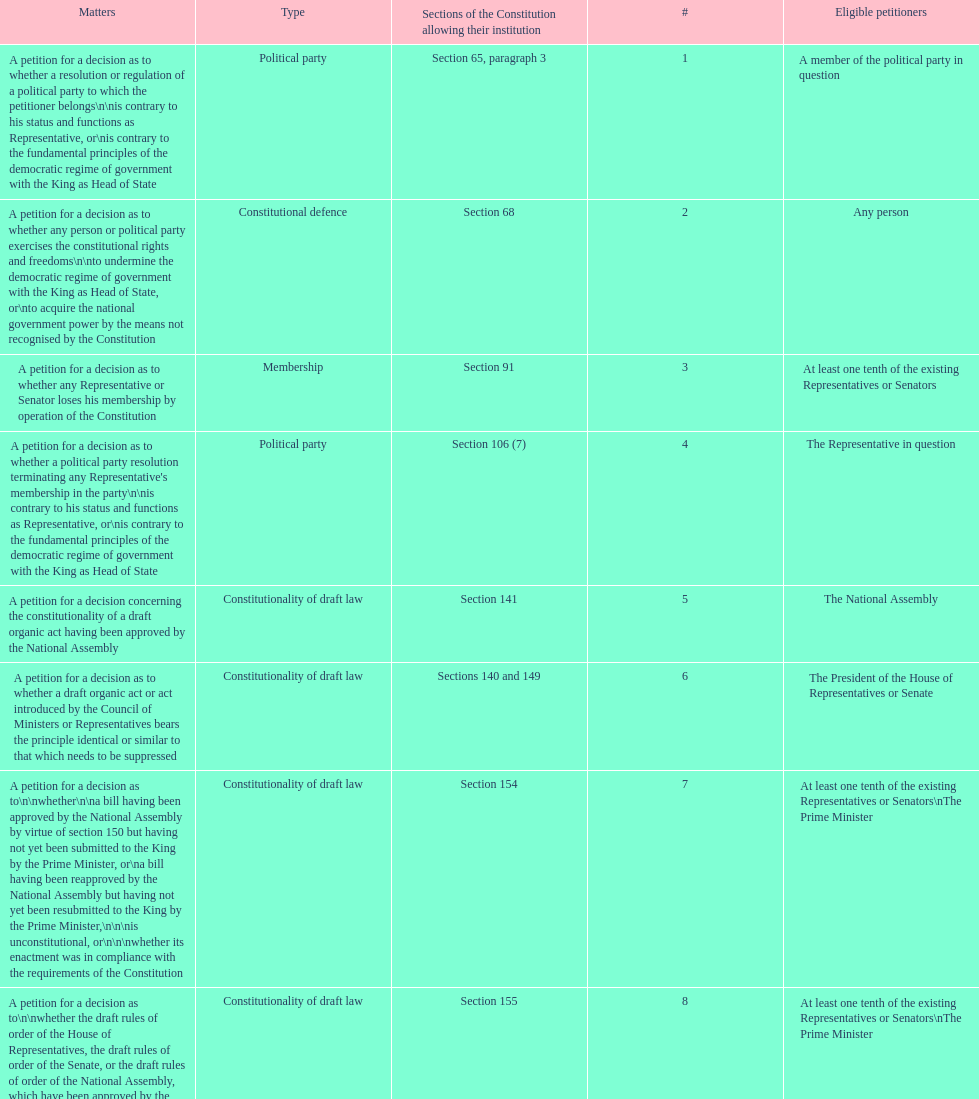How many matters require at least one tenth of the existing representatives or senators? 7. 